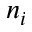<formula> <loc_0><loc_0><loc_500><loc_500>n _ { i }</formula> 